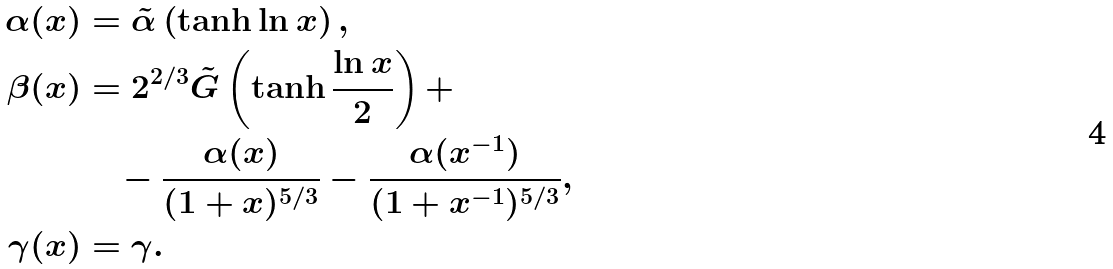Convert formula to latex. <formula><loc_0><loc_0><loc_500><loc_500>\alpha ( x ) & = \tilde { \alpha } \left ( \tanh \ln { x } \right ) , \\ \beta ( x ) & = 2 ^ { 2 / 3 } \tilde { G } \left ( \tanh \frac { \ln { x } } { 2 } \right ) + \\ & \quad - \frac { \alpha ( x ) } { ( 1 + x ) ^ { 5 / 3 } } - \frac { \alpha ( x ^ { - 1 } ) } { ( 1 + x ^ { - 1 } ) ^ { 5 / 3 } } , \\ \gamma ( x ) & = \gamma .</formula> 